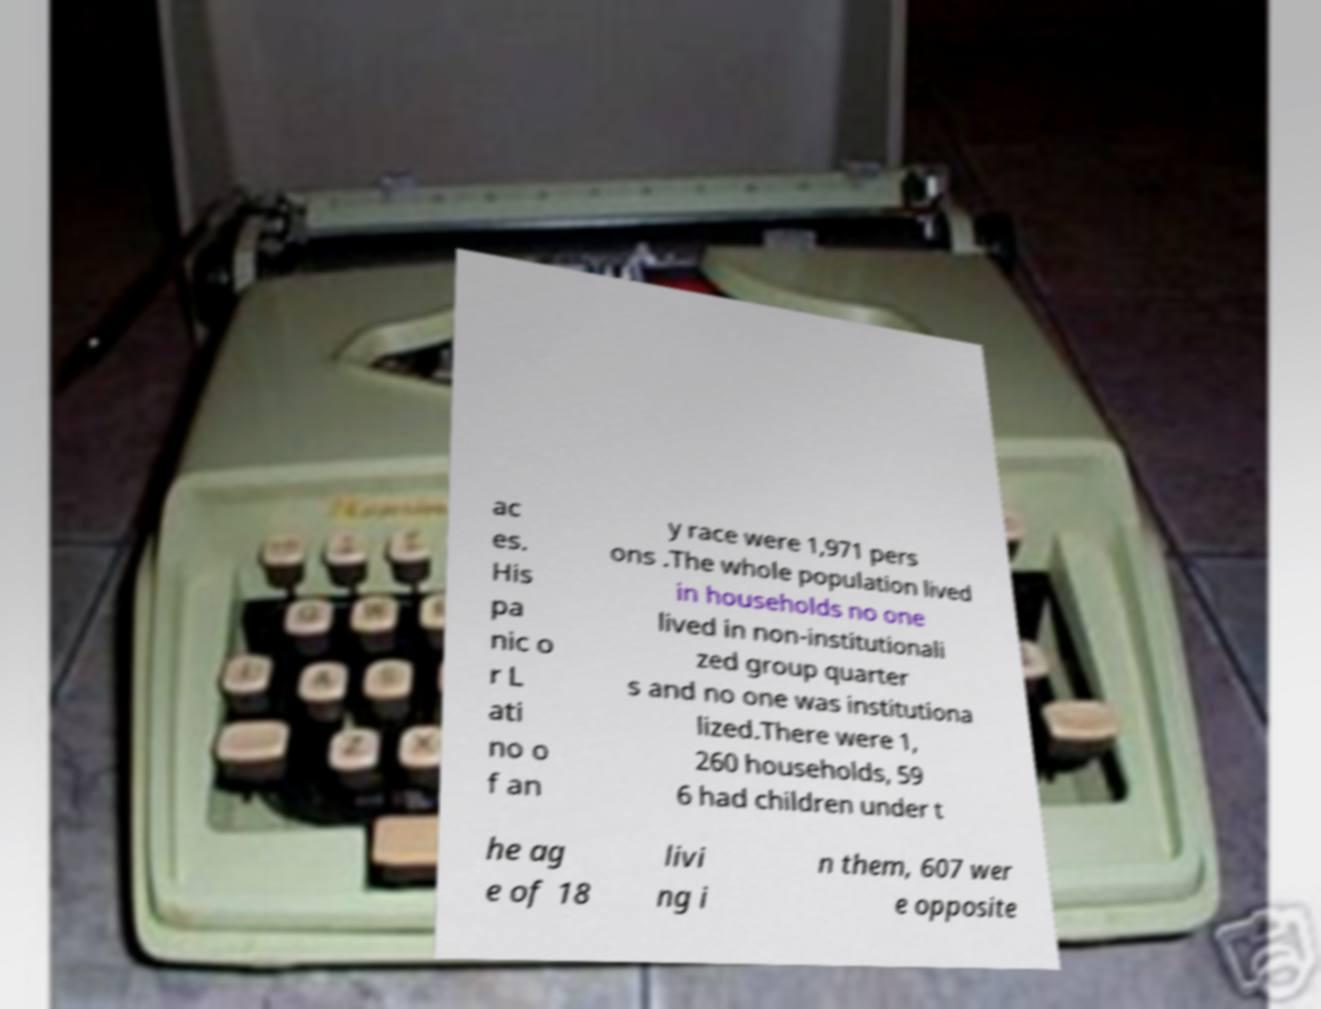I need the written content from this picture converted into text. Can you do that? ac es. His pa nic o r L ati no o f an y race were 1,971 pers ons .The whole population lived in households no one lived in non-institutionali zed group quarter s and no one was institutiona lized.There were 1, 260 households, 59 6 had children under t he ag e of 18 livi ng i n them, 607 wer e opposite 